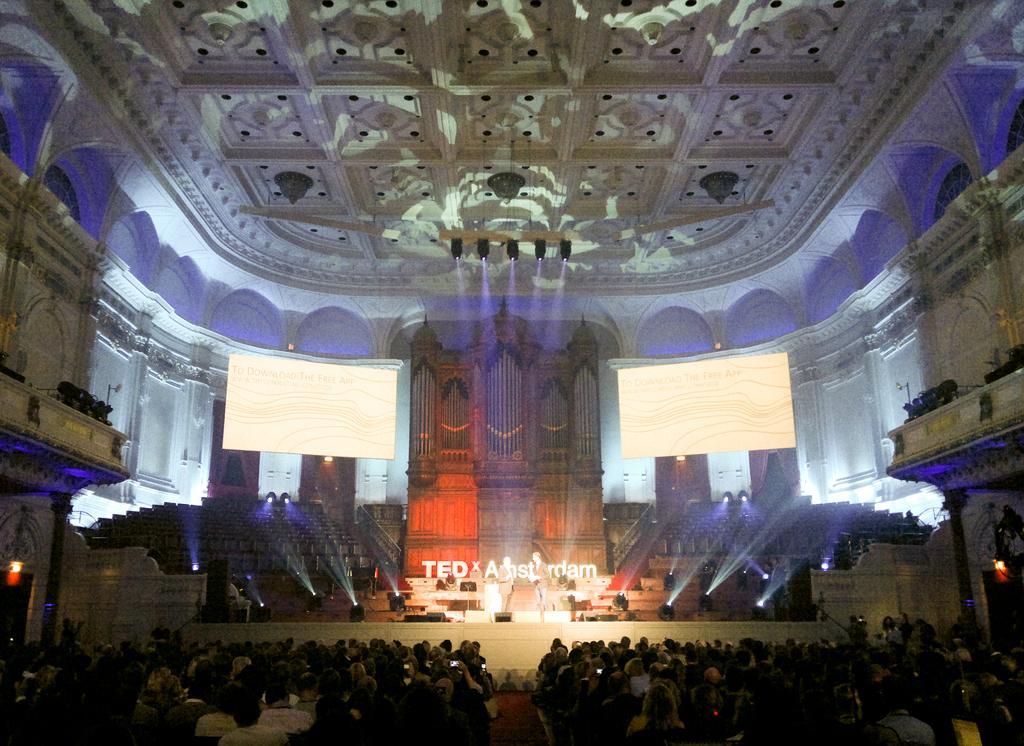Can you describe this image briefly? In this image we can see the inner view of a building and it looks like an auditorium and there are some people and we can see two persons standing on the stage. There are some stage lights and some other things on the stage and we can see two screens at the top and there are some lights attached to the ceiling. 